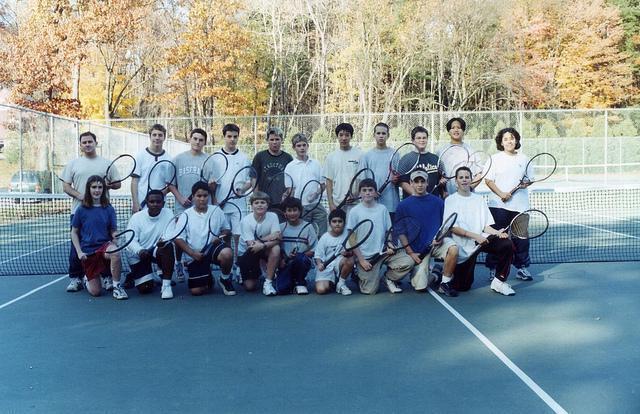How many people are not wearing white?
Give a very brief answer. 4. How many people are there?
Give a very brief answer. 11. How many orange trucks are there?
Give a very brief answer. 0. 